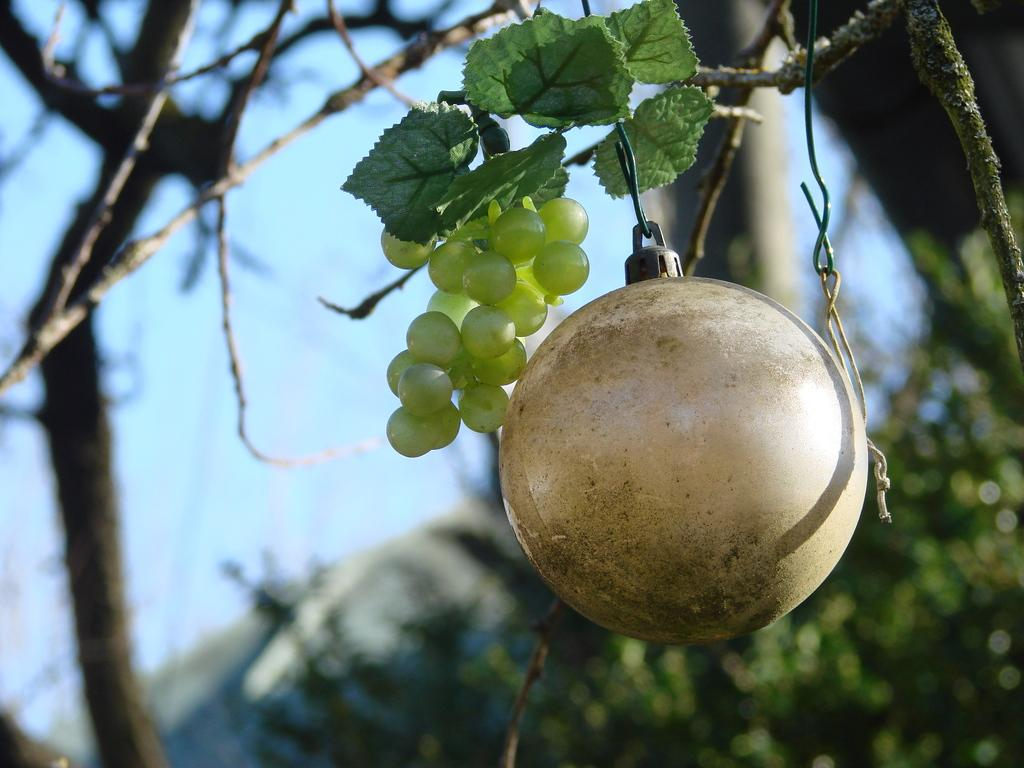What type of vegetation can be seen in the image? There are trees in the image. Are there any specific features of the trees? One of the trees has fruits. What is attached to the tree with fruits? There are objects on the tree with fruits. Can you describe the background of the image? The background of the image is blurred. What type of humor can be seen in the image? There is no humor present in the image; it features trees with fruits and objects attached to them. What type of care is being provided to the trees in the image? The image does not show any specific care being provided to the trees. 